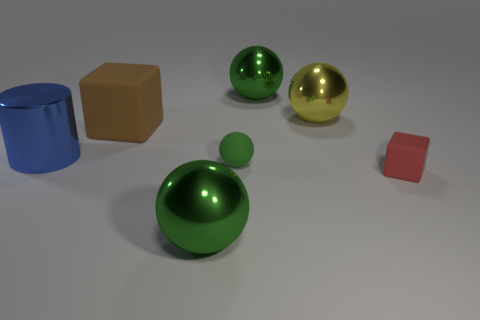Is the number of shiny spheres behind the yellow metallic sphere less than the number of small objects in front of the small green object?
Offer a very short reply. No. Is there any other thing that is the same shape as the yellow thing?
Offer a terse response. Yes. There is a big green ball that is to the right of the green metallic object that is in front of the big blue thing; how many large shiny objects are in front of it?
Provide a short and direct response. 3. There is a blue object; what number of tiny matte blocks are left of it?
Provide a succinct answer. 0. How many blue cylinders are the same material as the tiny red object?
Ensure brevity in your answer.  0. There is a tiny block that is the same material as the tiny green sphere; what is its color?
Provide a short and direct response. Red. What material is the ball that is in front of the matte cube to the right of the big ball that is in front of the large blue cylinder?
Ensure brevity in your answer.  Metal. There is a rubber block on the right side of the yellow metallic sphere; does it have the same size as the yellow shiny object?
Your answer should be compact. No. How many big things are either gray metallic balls or blue things?
Offer a very short reply. 1. Is there another small block of the same color as the small rubber cube?
Give a very brief answer. No. 